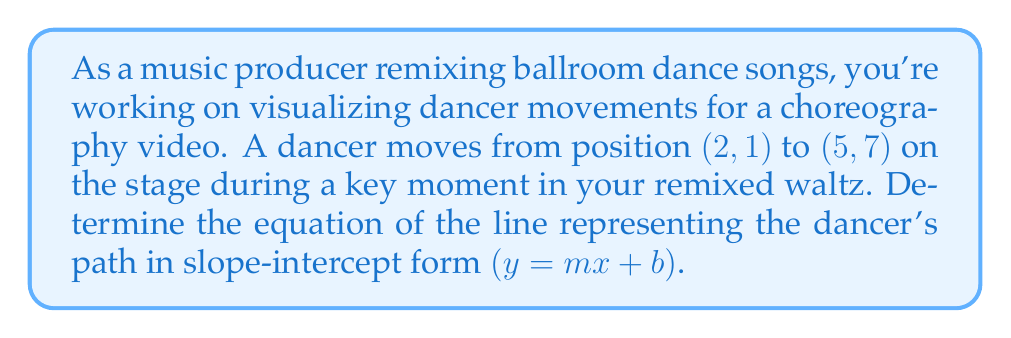Show me your answer to this math problem. To find the equation of the line passing through two points, we'll follow these steps:

1. Calculate the slope $(m)$ using the slope formula:
   $$m = \frac{y_2 - y_1}{x_2 - x_1}$$

   Where $(x_1, y_1)$ is the first point and $(x_2, y_2)$ is the second point.

2. Substitute the given points:
   $$m = \frac{7 - 1}{5 - 2} = \frac{6}{3} = 2$$

3. Use the point-slope form of a line with one of the given points:
   $$y - y_1 = m(x - x_1)$$

4. Substitute the slope and the first point $(2, 1)$:
   $$y - 1 = 2(x - 2)$$

5. Expand the equation:
   $$y - 1 = 2x - 4$$

6. Solve for $y$ to get the slope-intercept form:
   $$y = 2x - 4 + 1$$
   $$y = 2x - 3$$

Therefore, the equation of the line representing the dancer's path in slope-intercept form is $y = 2x - 3$.
Answer: $y = 2x - 3$ 